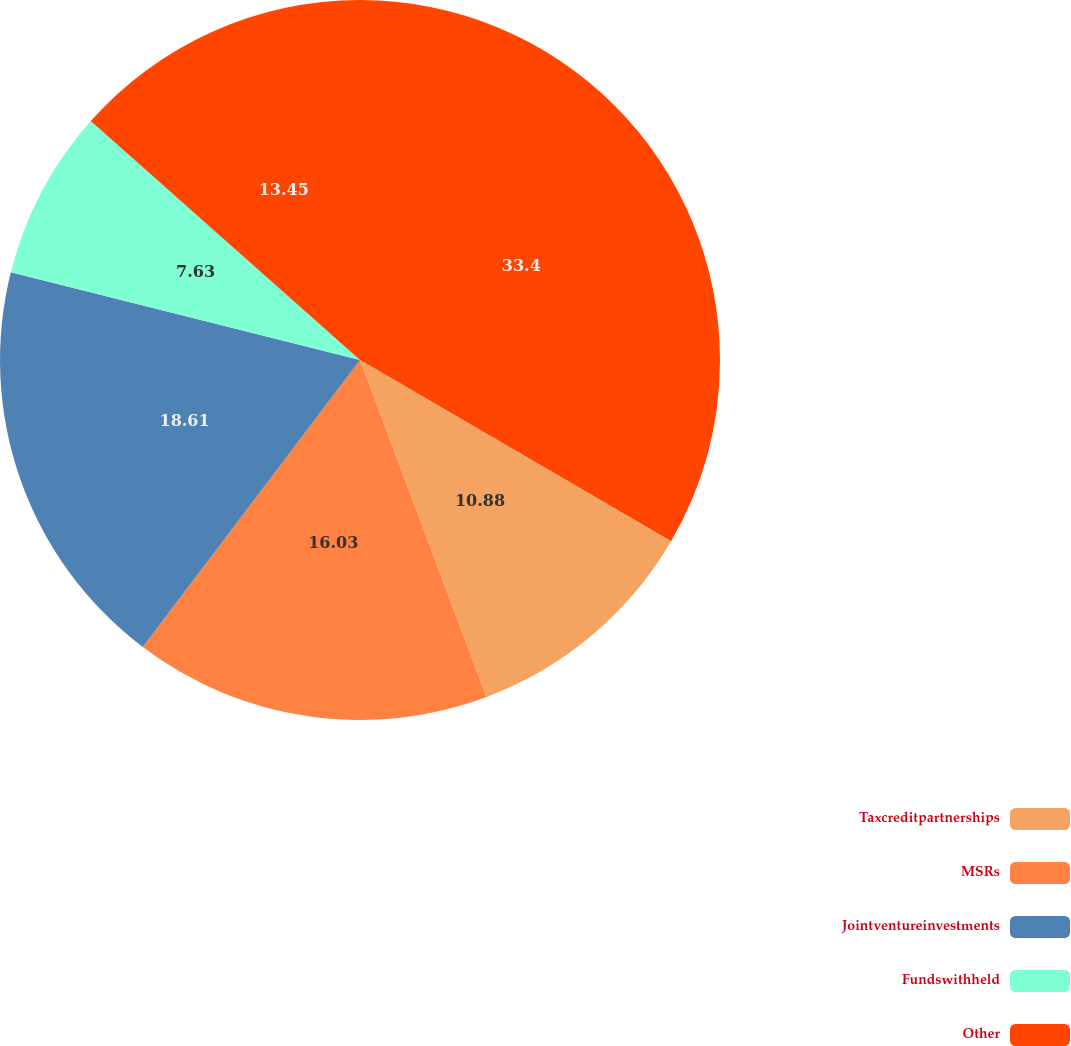Convert chart to OTSL. <chart><loc_0><loc_0><loc_500><loc_500><pie_chart><ecel><fcel>Taxcreditpartnerships<fcel>MSRs<fcel>Jointventureinvestments<fcel>Fundswithheld<fcel>Other<nl><fcel>33.4%<fcel>10.88%<fcel>16.03%<fcel>18.61%<fcel>7.63%<fcel>13.45%<nl></chart> 